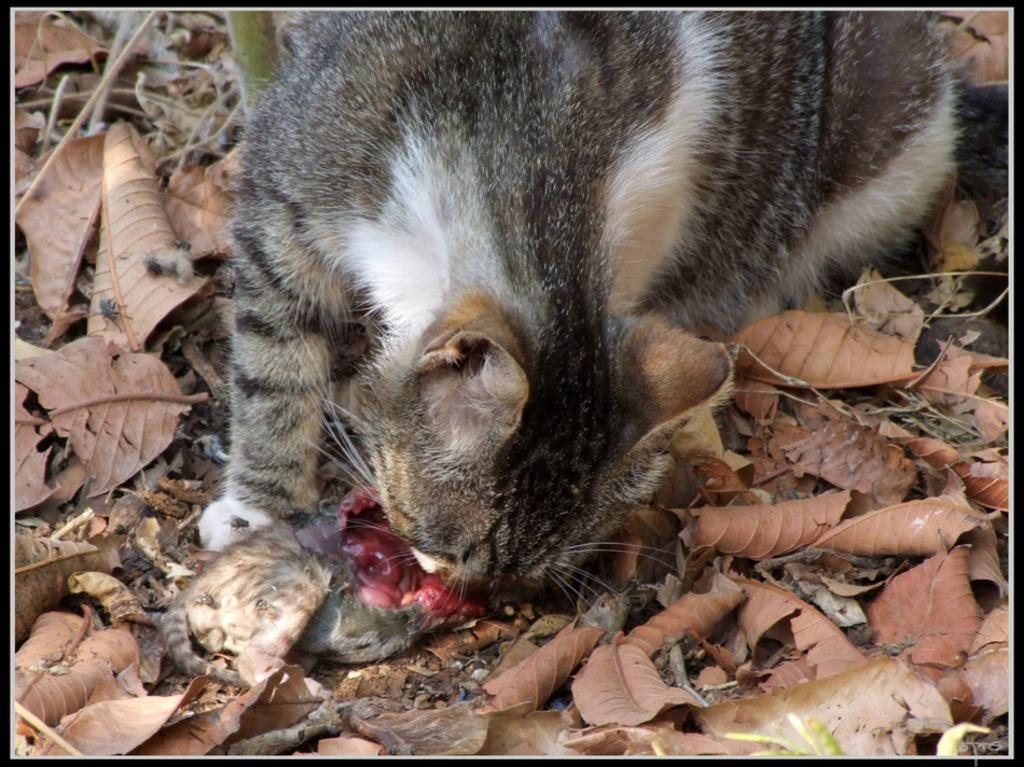What type of animal is in the image? There is a cat in the image. Can you describe the appearance of the cat? The cat is black and white in color. What is the cat doing in the image? The cat is eating an animal. Where is the animal located in the image? The animal is on the ground. What else can be seen on the ground in the image? There are dry leaves on the ground. What type of club does the cat belong to in the image? There is no mention of a club in the image, and the cat does not belong to any club. What type of system is the cat using to eat the animal in the image? The cat is using its natural instincts and abilities to eat the animal, and there is no specific system involved. 